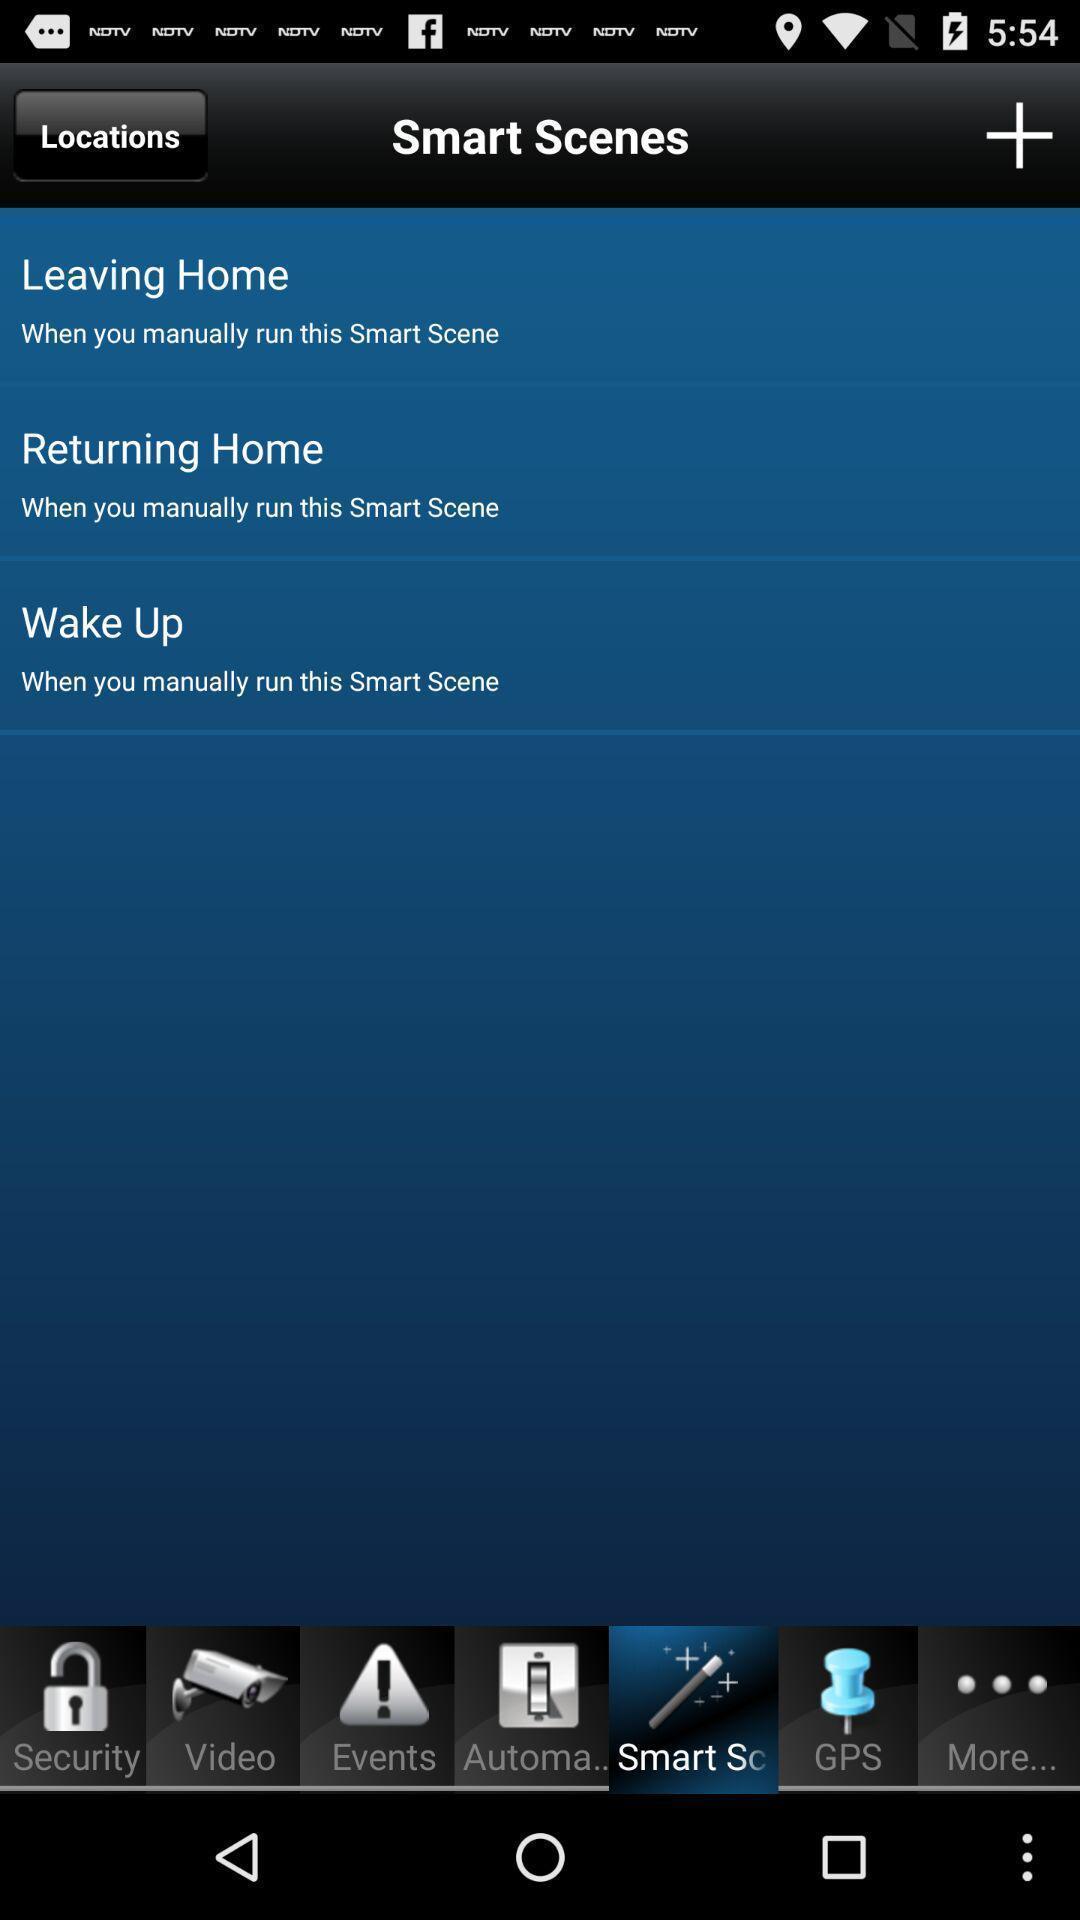Describe this image in words. Smart scenes of a home. 